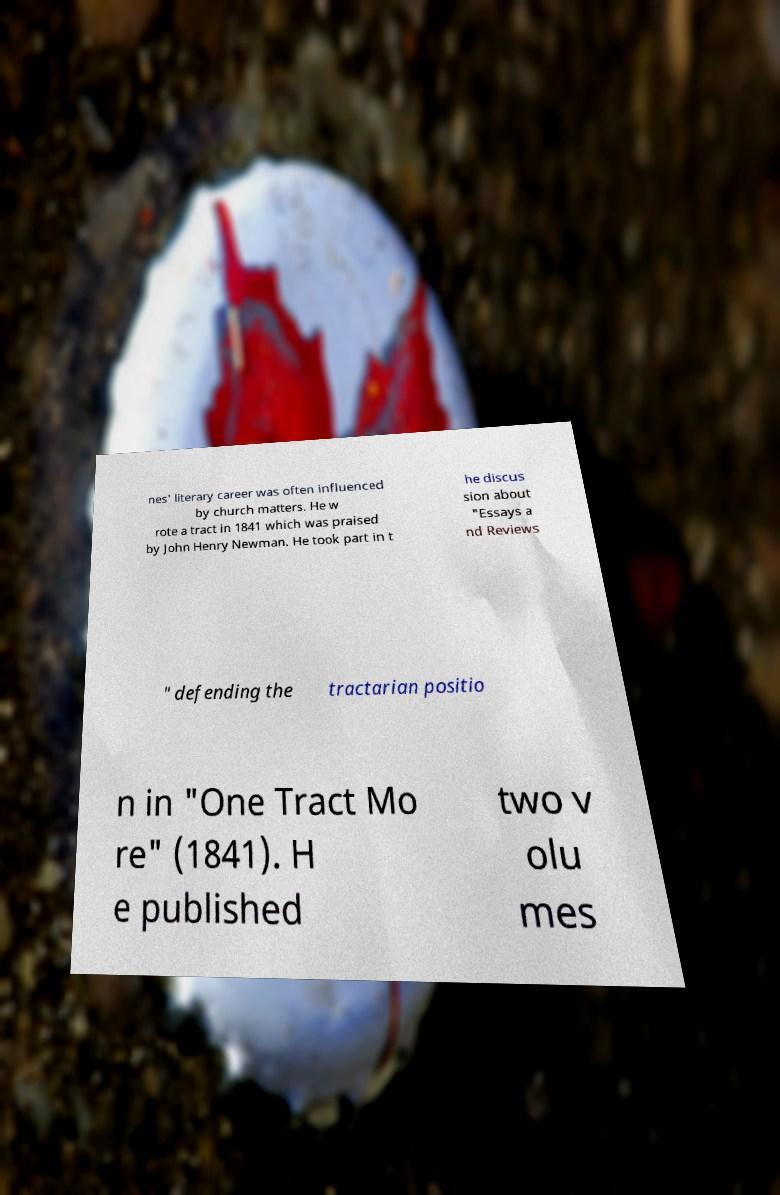Please identify and transcribe the text found in this image. nes' literary career was often influenced by church matters. He w rote a tract in 1841 which was praised by John Henry Newman. He took part in t he discus sion about "Essays a nd Reviews " defending the tractarian positio n in "One Tract Mo re" (1841). H e published two v olu mes 